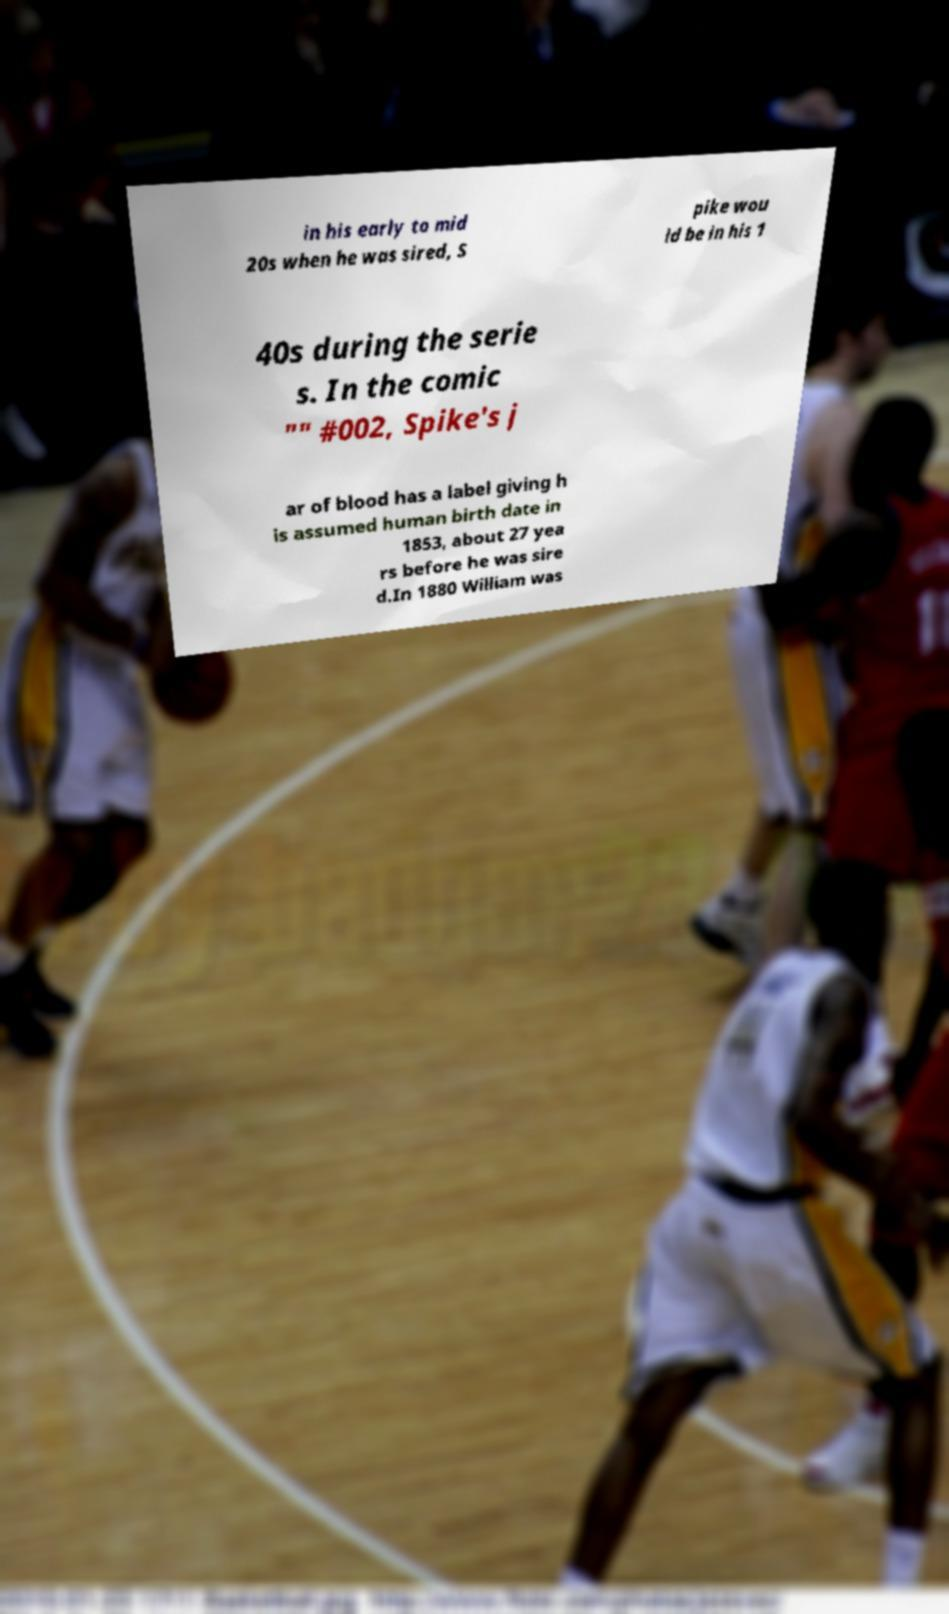What messages or text are displayed in this image? I need them in a readable, typed format. in his early to mid 20s when he was sired, S pike wou ld be in his 1 40s during the serie s. In the comic "" #002, Spike's j ar of blood has a label giving h is assumed human birth date in 1853, about 27 yea rs before he was sire d.In 1880 William was 